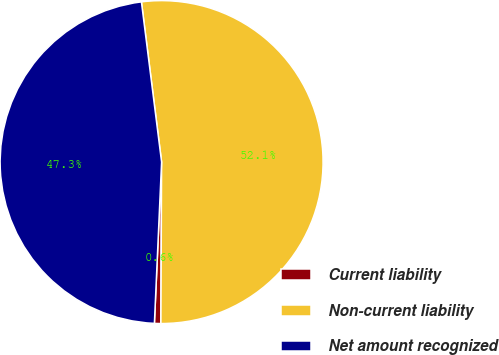<chart> <loc_0><loc_0><loc_500><loc_500><pie_chart><fcel>Current liability<fcel>Non-current liability<fcel>Net amount recognized<nl><fcel>0.64%<fcel>52.07%<fcel>47.3%<nl></chart> 